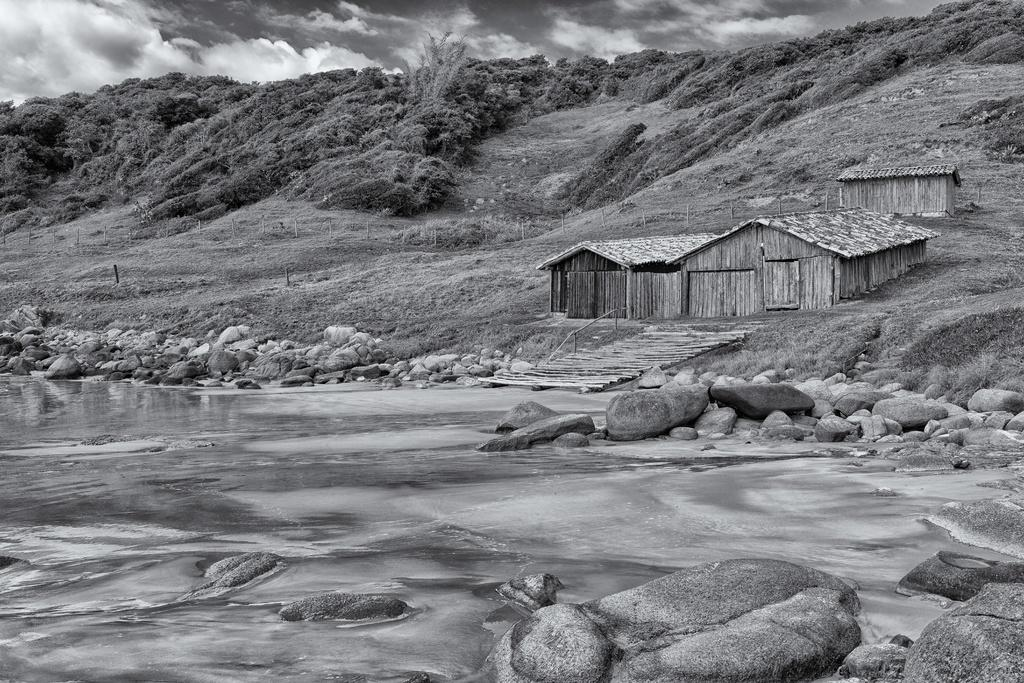What is present in the image that is related to sports? There are hits in the image, which could be related to sports like baseball or cricket. What type of natural environment is depicted in the image? The image features trees, grass, and water, indicating a natural environment. What structures are visible in the image? There are poles in the image, which could be part of a fence or a support structure. What is the condition of the sky in the image? The sky is cloudy at the top of the image. What type of terrain is present in the image? The image includes grass and stones, suggesting a mix of grassy and rocky terrain. What type of gate can be seen in the image? There is no gate present in the image. How does the acoustics of the image affect the sound of the hits? The image does not provide any information about the acoustics, as it is a still image and not a recording of sound. What type of cup is being used to collect the water in the image? There is no cup present in the image; water is flowing freely. 